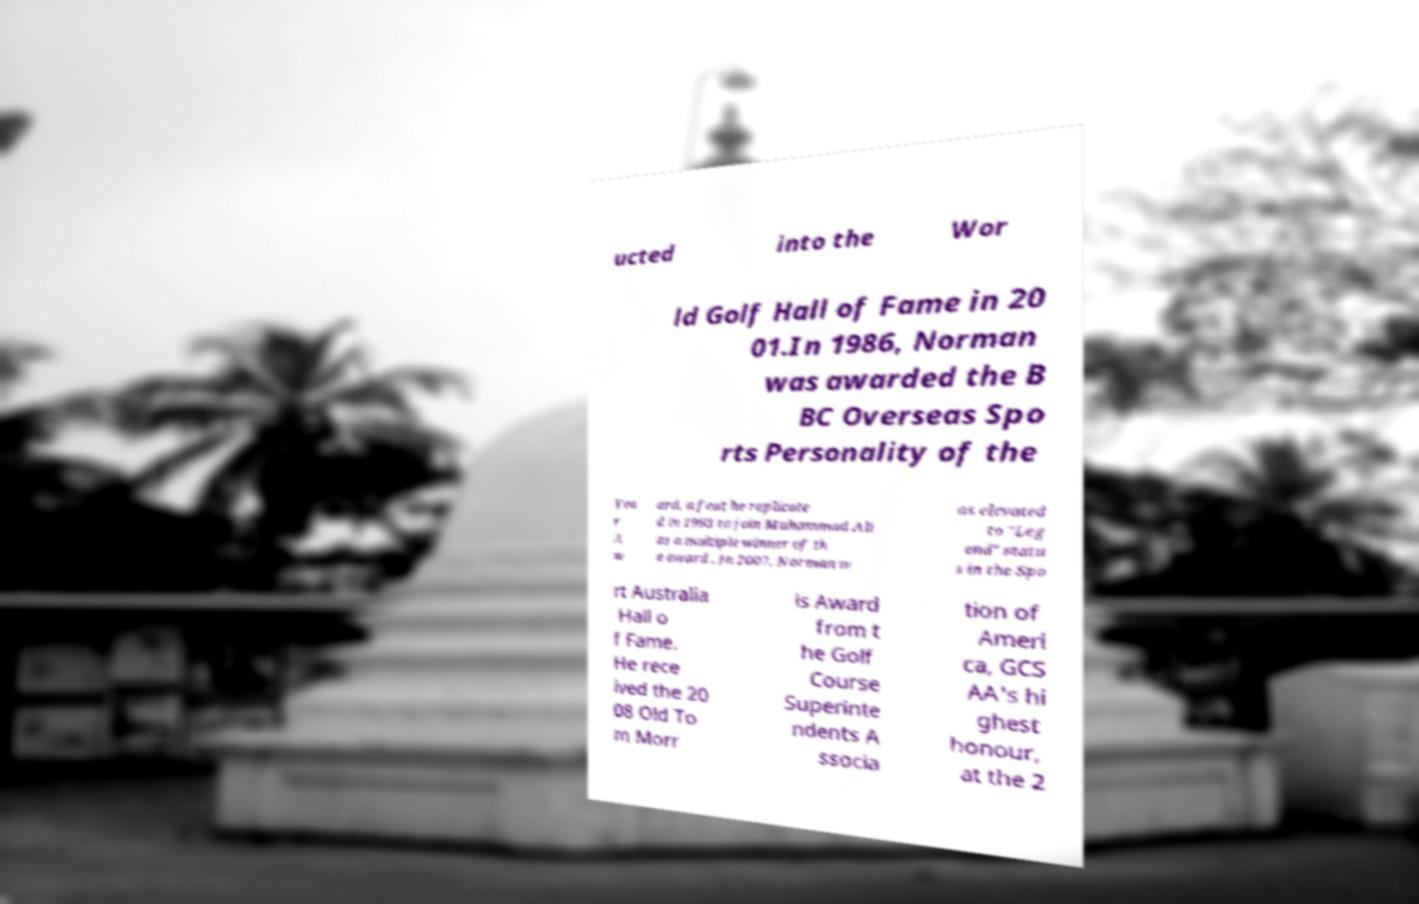Can you read and provide the text displayed in the image?This photo seems to have some interesting text. Can you extract and type it out for me? ucted into the Wor ld Golf Hall of Fame in 20 01.In 1986, Norman was awarded the B BC Overseas Spo rts Personality of the Yea r A w ard, a feat he replicate d in 1993 to join Muhammad Ali as a multiple winner of th e award . In 2007, Norman w as elevated to "Leg end" statu s in the Spo rt Australia Hall o f Fame. He rece ived the 20 08 Old To m Morr is Award from t he Golf Course Superinte ndents A ssocia tion of Ameri ca, GCS AA's hi ghest honour, at the 2 